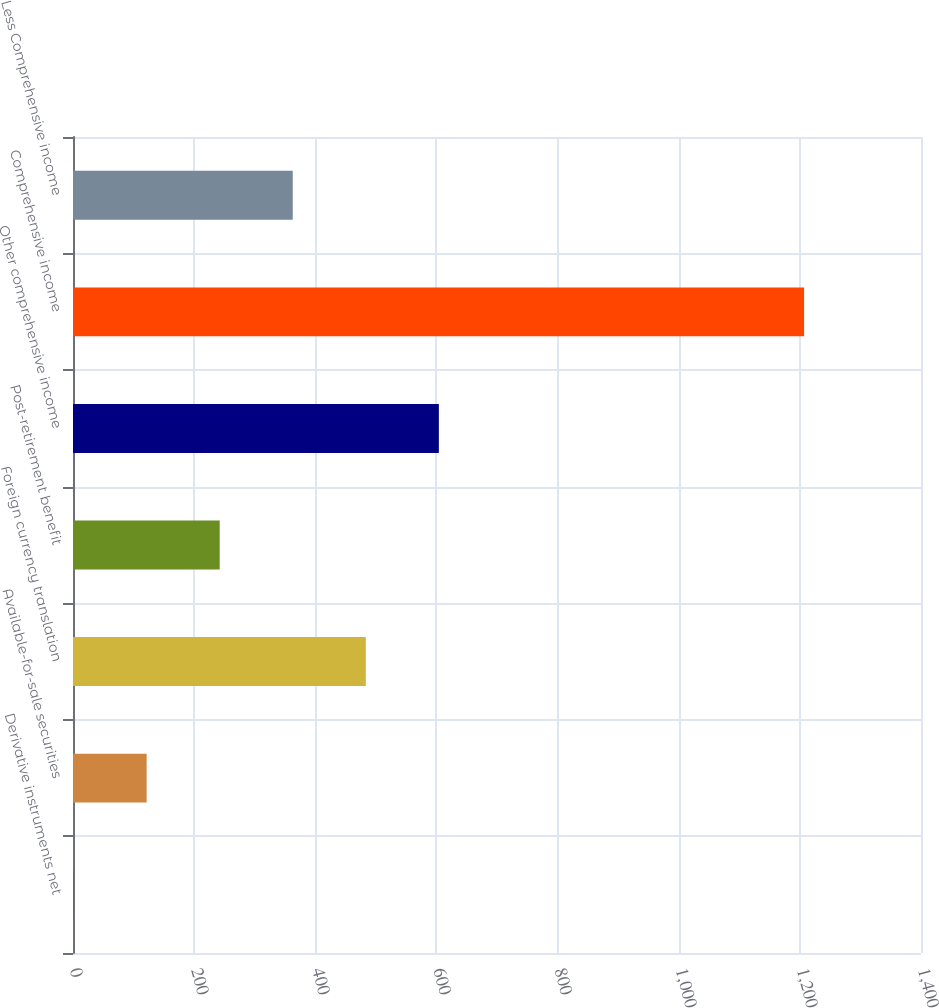<chart> <loc_0><loc_0><loc_500><loc_500><bar_chart><fcel>Derivative instruments net<fcel>Available-for-sale securities<fcel>Foreign currency translation<fcel>Post-retirement benefit<fcel>Other comprehensive income<fcel>Comprehensive income<fcel>Less Comprehensive income<nl><fcel>1<fcel>121.6<fcel>483.4<fcel>242.2<fcel>604<fcel>1207<fcel>362.8<nl></chart> 